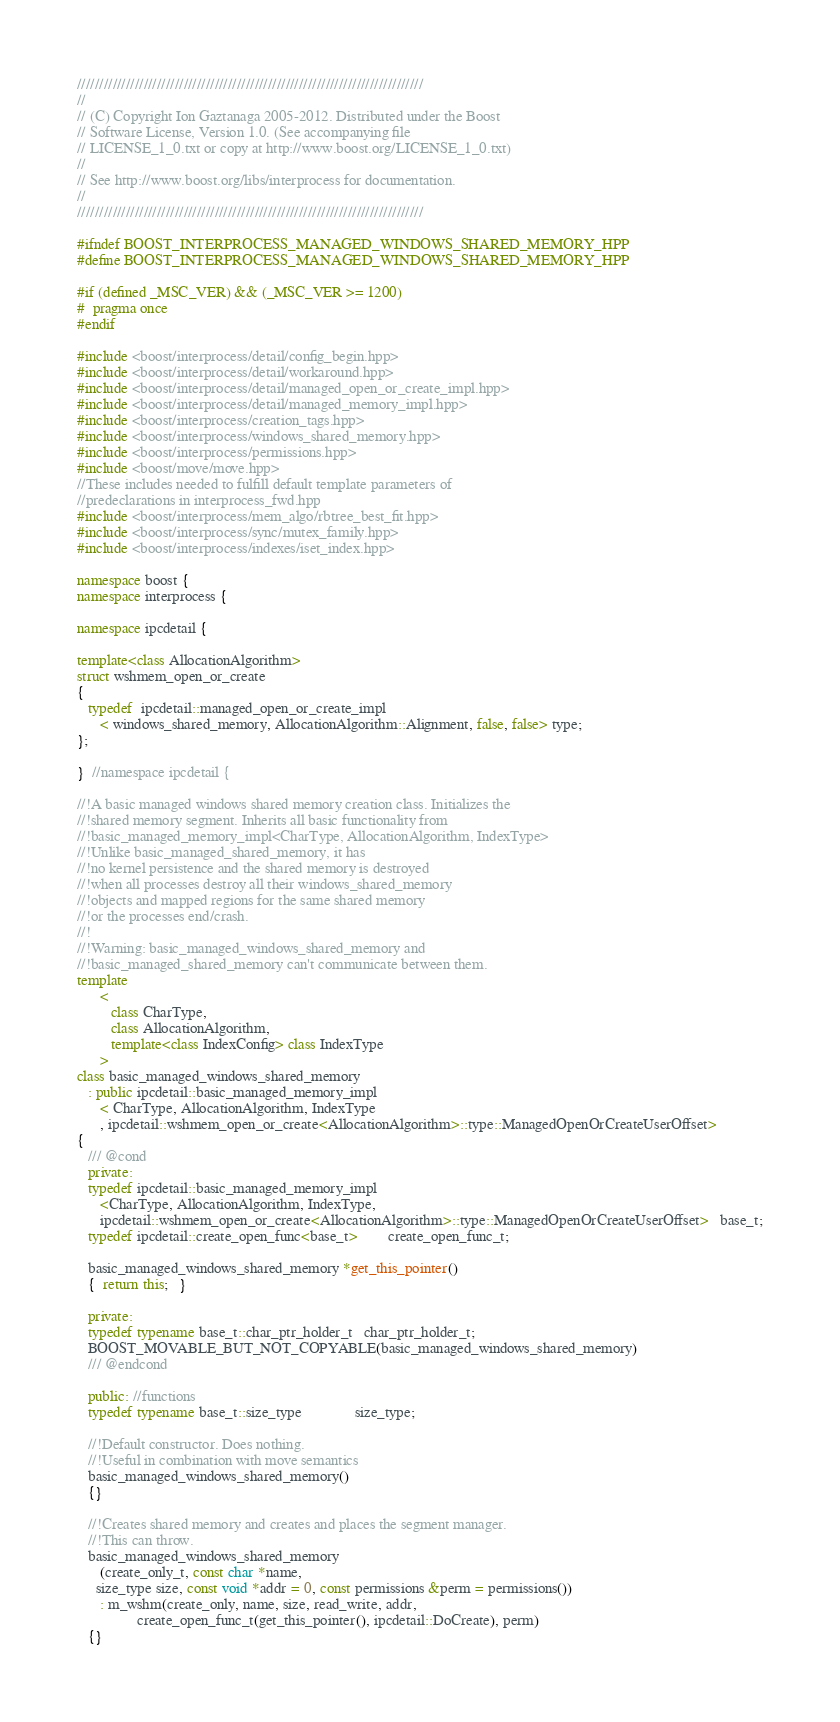Convert code to text. <code><loc_0><loc_0><loc_500><loc_500><_C++_>//////////////////////////////////////////////////////////////////////////////
//
// (C) Copyright Ion Gaztanaga 2005-2012. Distributed under the Boost
// Software License, Version 1.0. (See accompanying file
// LICENSE_1_0.txt or copy at http://www.boost.org/LICENSE_1_0.txt)
//
// See http://www.boost.org/libs/interprocess for documentation.
//
//////////////////////////////////////////////////////////////////////////////

#ifndef BOOST_INTERPROCESS_MANAGED_WINDOWS_SHARED_MEMORY_HPP
#define BOOST_INTERPROCESS_MANAGED_WINDOWS_SHARED_MEMORY_HPP

#if (defined _MSC_VER) && (_MSC_VER >= 1200)
#  pragma once
#endif

#include <boost/interprocess/detail/config_begin.hpp>
#include <boost/interprocess/detail/workaround.hpp>
#include <boost/interprocess/detail/managed_open_or_create_impl.hpp>
#include <boost/interprocess/detail/managed_memory_impl.hpp>
#include <boost/interprocess/creation_tags.hpp>
#include <boost/interprocess/windows_shared_memory.hpp>
#include <boost/interprocess/permissions.hpp>
#include <boost/move/move.hpp>
//These includes needed to fulfill default template parameters of
//predeclarations in interprocess_fwd.hpp
#include <boost/interprocess/mem_algo/rbtree_best_fit.hpp>
#include <boost/interprocess/sync/mutex_family.hpp>
#include <boost/interprocess/indexes/iset_index.hpp>

namespace boost {
namespace interprocess {

namespace ipcdetail {

template<class AllocationAlgorithm>
struct wshmem_open_or_create
{
   typedef  ipcdetail::managed_open_or_create_impl
      < windows_shared_memory, AllocationAlgorithm::Alignment, false, false> type;
};

}  //namespace ipcdetail {

//!A basic managed windows shared memory creation class. Initializes the
//!shared memory segment. Inherits all basic functionality from
//!basic_managed_memory_impl<CharType, AllocationAlgorithm, IndexType>
//!Unlike basic_managed_shared_memory, it has
//!no kernel persistence and the shared memory is destroyed
//!when all processes destroy all their windows_shared_memory
//!objects and mapped regions for the same shared memory
//!or the processes end/crash.
//!
//!Warning: basic_managed_windows_shared_memory and
//!basic_managed_shared_memory can't communicate between them.
template
      <
         class CharType,
         class AllocationAlgorithm,
         template<class IndexConfig> class IndexType
      >
class basic_managed_windows_shared_memory
   : public ipcdetail::basic_managed_memory_impl
      < CharType, AllocationAlgorithm, IndexType
      , ipcdetail::wshmem_open_or_create<AllocationAlgorithm>::type::ManagedOpenOrCreateUserOffset>
{
   /// @cond
   private:
   typedef ipcdetail::basic_managed_memory_impl
      <CharType, AllocationAlgorithm, IndexType,
      ipcdetail::wshmem_open_or_create<AllocationAlgorithm>::type::ManagedOpenOrCreateUserOffset>   base_t;
   typedef ipcdetail::create_open_func<base_t>        create_open_func_t;

   basic_managed_windows_shared_memory *get_this_pointer()
   {  return this;   }

   private:
   typedef typename base_t::char_ptr_holder_t   char_ptr_holder_t;
   BOOST_MOVABLE_BUT_NOT_COPYABLE(basic_managed_windows_shared_memory)
   /// @endcond

   public: //functions
   typedef typename base_t::size_type              size_type;

   //!Default constructor. Does nothing.
   //!Useful in combination with move semantics
   basic_managed_windows_shared_memory()
   {}

   //!Creates shared memory and creates and places the segment manager.
   //!This can throw.
   basic_managed_windows_shared_memory
      (create_only_t, const char *name,
     size_type size, const void *addr = 0, const permissions &perm = permissions())
      : m_wshm(create_only, name, size, read_write, addr,
                create_open_func_t(get_this_pointer(), ipcdetail::DoCreate), perm)
   {}
</code> 